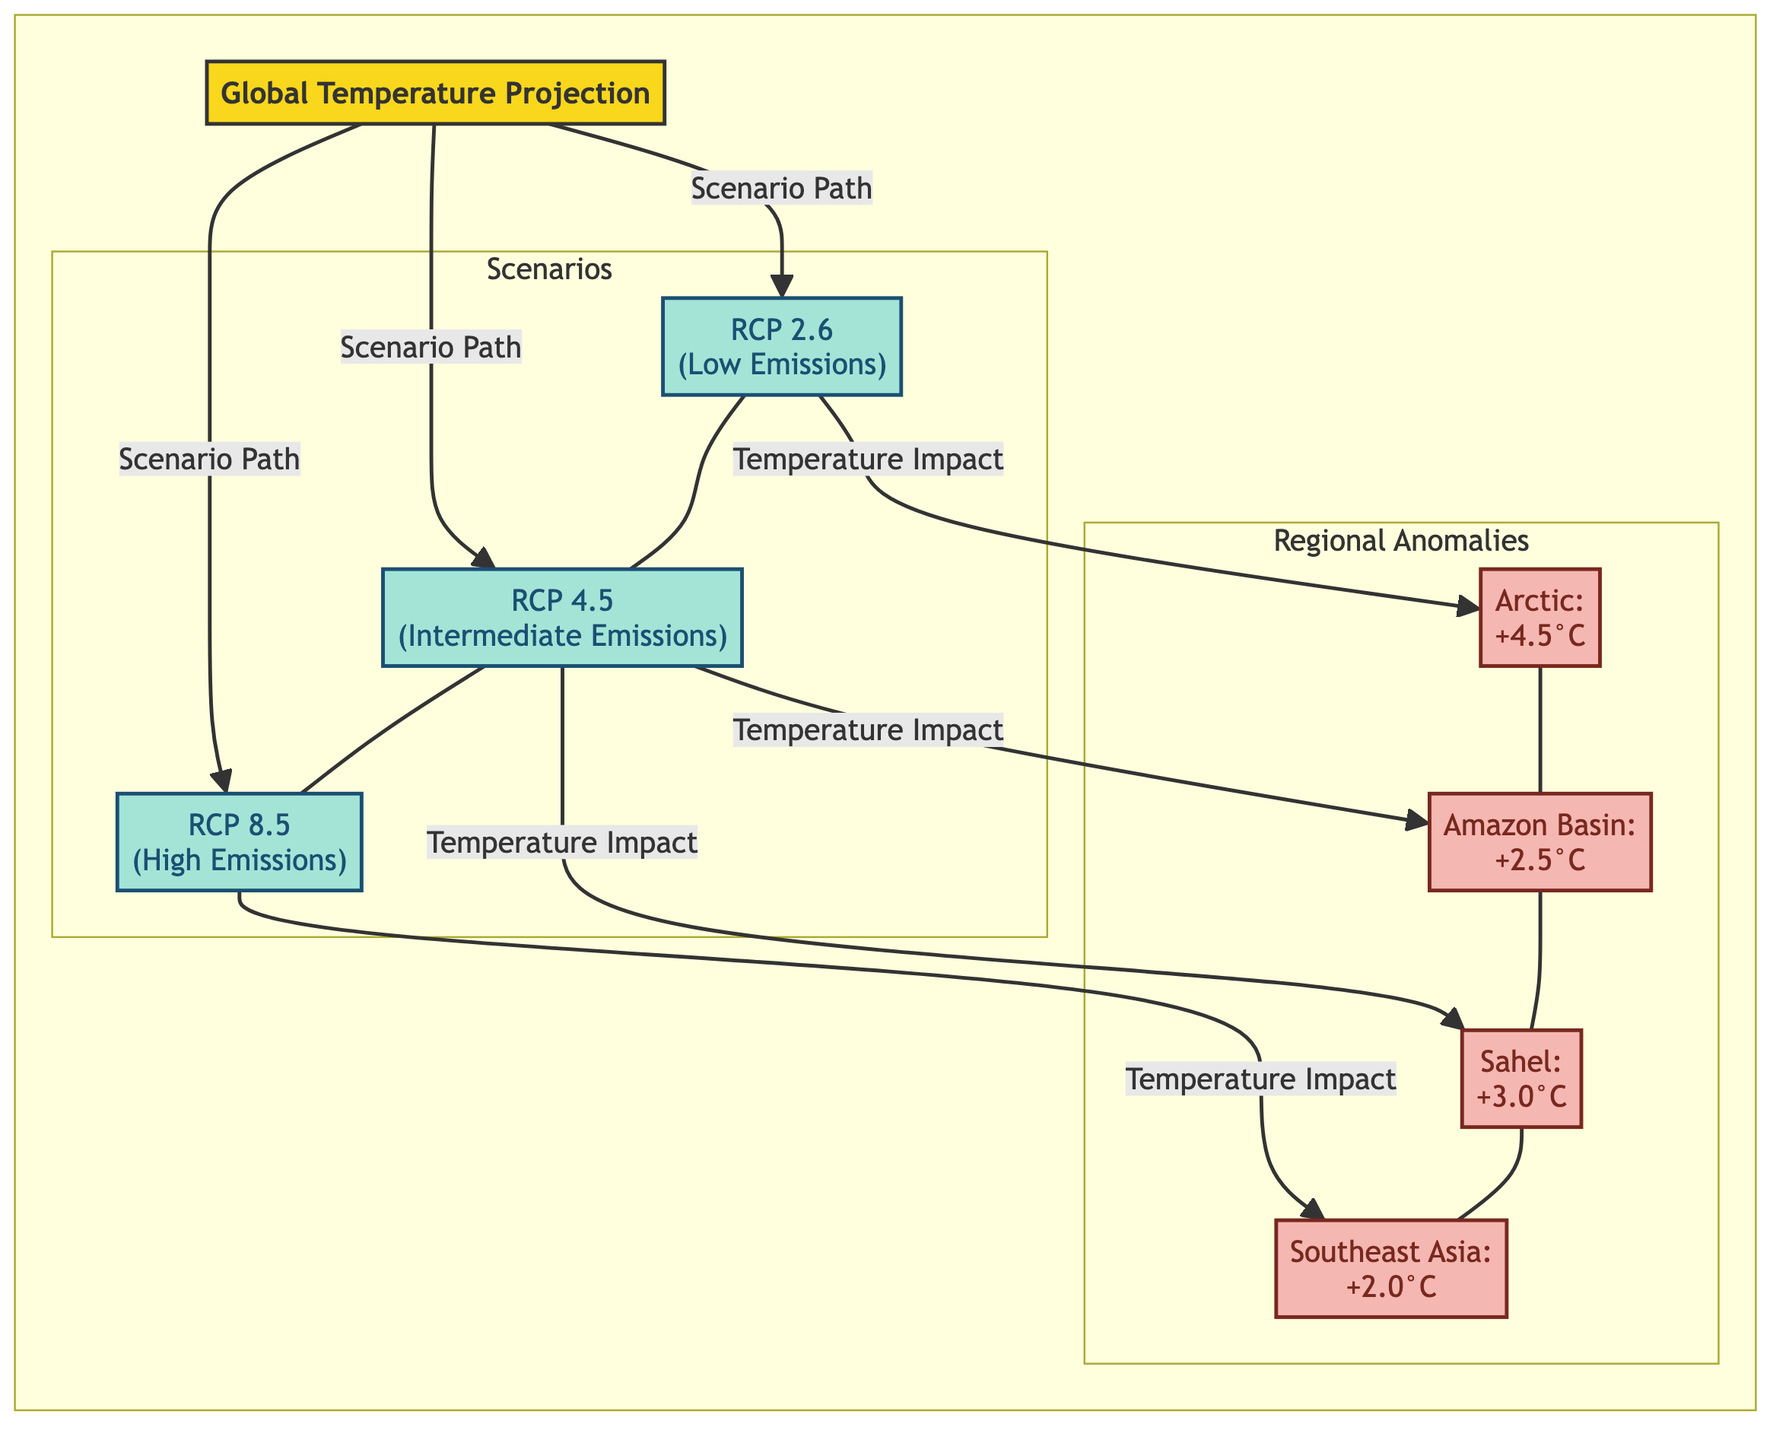What are the emission scenarios depicted in the diagram? The diagram outlines three emission scenarios: RCP 2.6, RCP 4.5, and RCP 8.5, which represent low, intermediate, and high emissions respectively.
Answer: RCP 2.6, RCP 4.5, RCP 8.5 Which region shows the highest temperature anomaly? By comparing the temperature anomalies listed, the Arctic region at +4.5°C is the highest among the others listed in the diagram.
Answer: Arctic: +4.5°C How many temperature anomalies are presented in the diagram? The diagram displays a total of four temperature anomalies: Arctic, Amazon Basin, Sahel, and Southeast Asia. This is determined by counting each labeled anomaly node.
Answer: 4 What is the temperature anomaly for the Amazon Basin under the RCP 4.5 scenario? The diagram indicates that the temperature anomaly for the Amazon Basin under the RCP 4.5 scenario is +2.5°C, directly stated within the respective node.
Answer: +2.5°C Which emission scenario is projected to have a temperature impact on Southeast Asia? The diagram shows that Southeast Asia's temperature impact is linked to the RCP 8.5 scenario, as depicted by the arrow connecting these two nodes.
Answer: RCP 8.5 How many scenarios are linked to the Arctic temperature anomaly? The Arctic anomaly is only linked to the RCP 2.6 scenario in the diagram, indicating that this is the only projected scenario for this region's temperature anomaly.
Answer: 1 Which two regions are projected to have a temperature anomaly of +3.0°C? The Sahel region is projected with a temperature anomaly of +3.0°C, and no other region is indicated with the same anomaly within the diagram, therefore the answer is solely Sahel.
Answer: Sahel What type of diagram is this? The structure of the diagram displays a flowchart format, which illustrates the relationship and transitions between scenarios and regional anomalies respective to global temperature projections.
Answer: Flowchart 